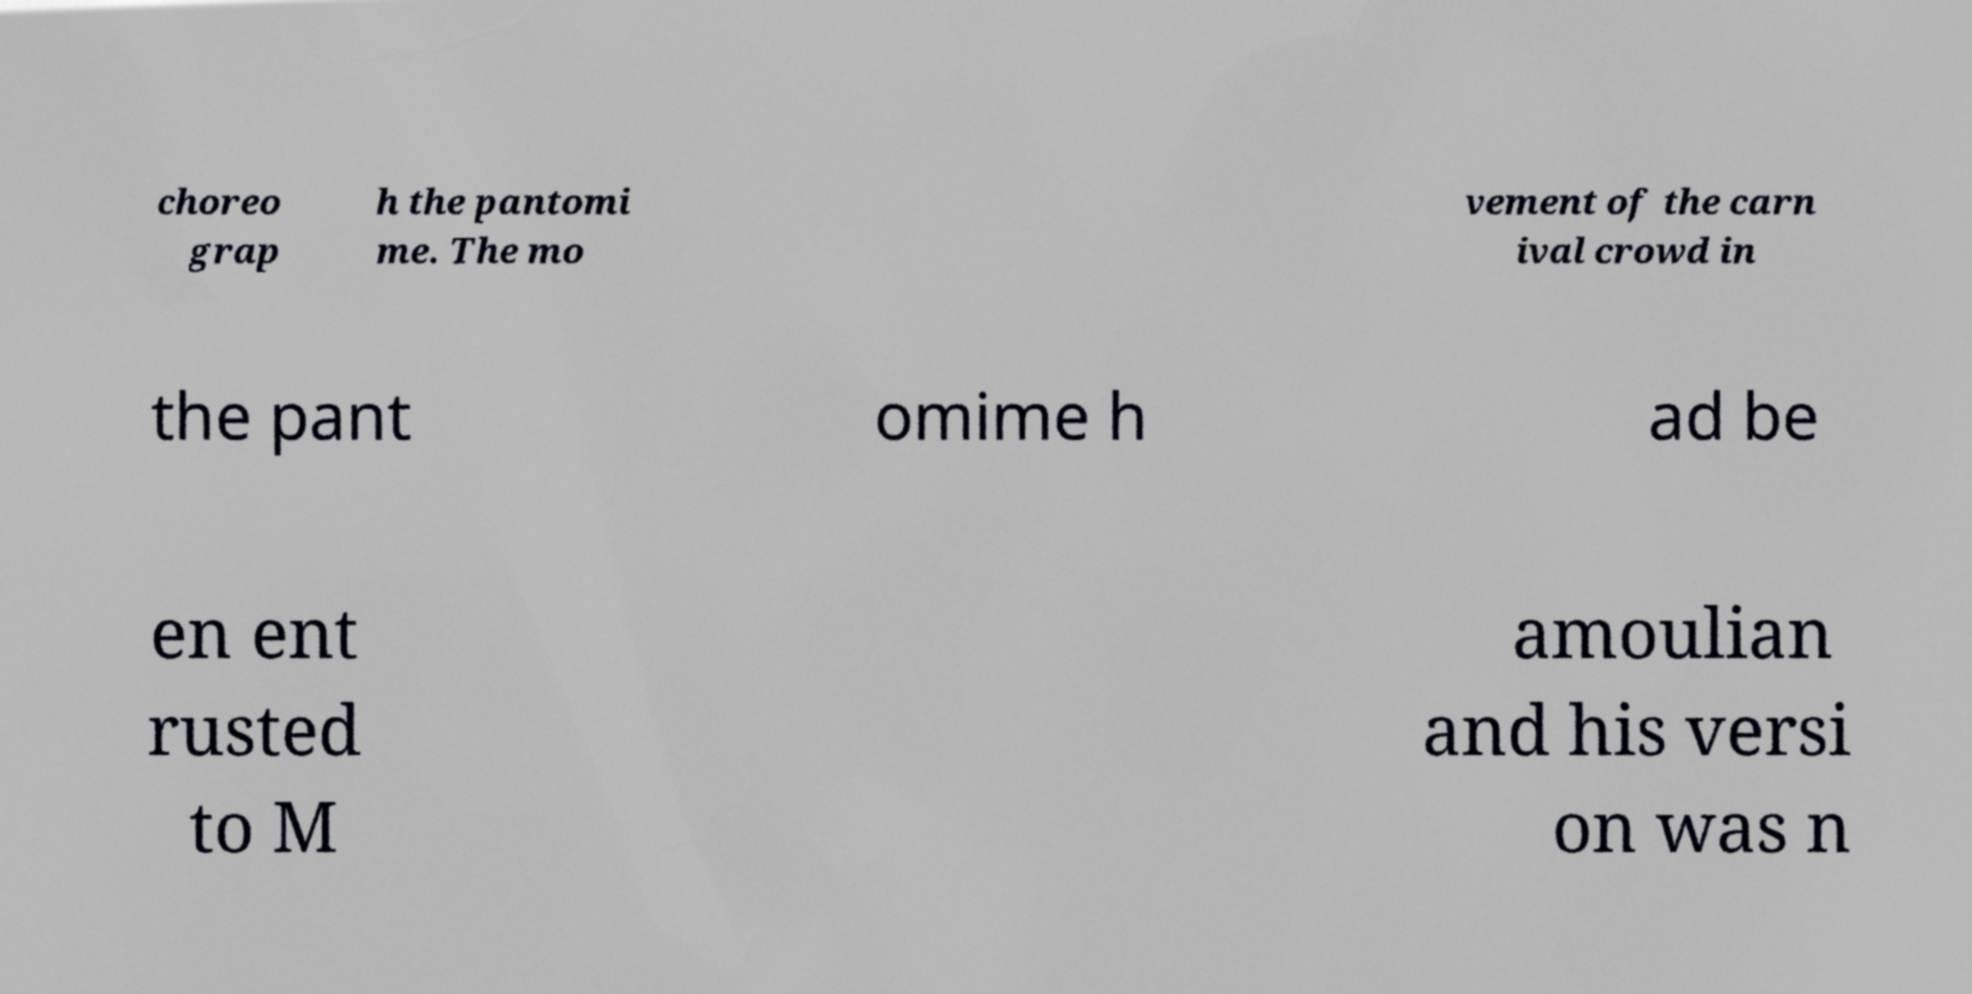Can you accurately transcribe the text from the provided image for me? choreo grap h the pantomi me. The mo vement of the carn ival crowd in the pant omime h ad be en ent rusted to M amoulian and his versi on was n 